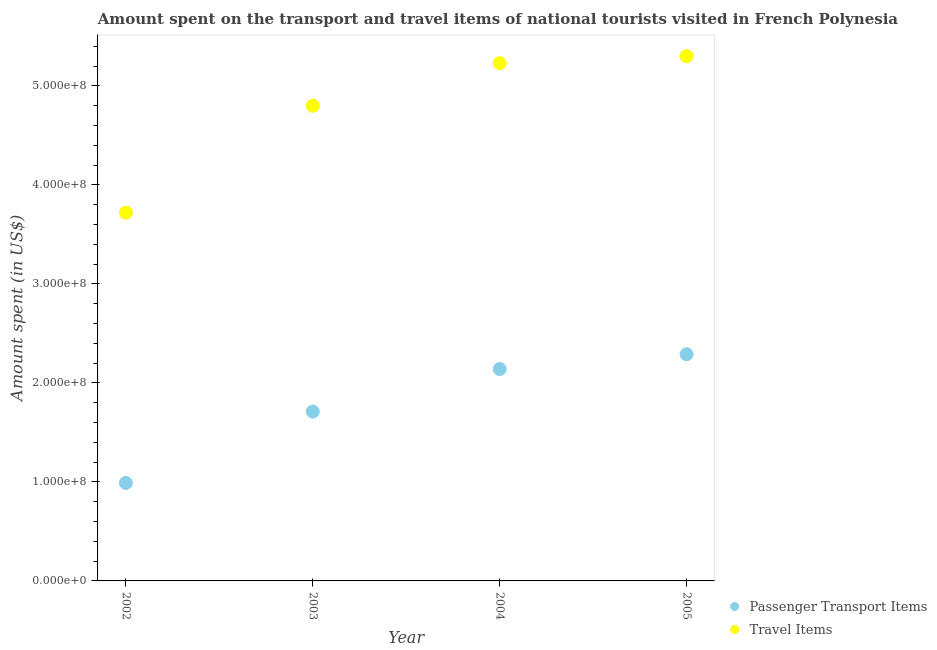How many different coloured dotlines are there?
Ensure brevity in your answer.  2. What is the amount spent in travel items in 2003?
Your answer should be very brief. 4.80e+08. Across all years, what is the maximum amount spent in travel items?
Offer a terse response. 5.30e+08. Across all years, what is the minimum amount spent on passenger transport items?
Give a very brief answer. 9.90e+07. In which year was the amount spent in travel items maximum?
Your response must be concise. 2005. What is the total amount spent on passenger transport items in the graph?
Provide a succinct answer. 7.13e+08. What is the difference between the amount spent on passenger transport items in 2004 and that in 2005?
Make the answer very short. -1.50e+07. What is the difference between the amount spent in travel items in 2002 and the amount spent on passenger transport items in 2004?
Ensure brevity in your answer.  1.58e+08. What is the average amount spent in travel items per year?
Ensure brevity in your answer.  4.76e+08. In the year 2003, what is the difference between the amount spent in travel items and amount spent on passenger transport items?
Offer a very short reply. 3.09e+08. In how many years, is the amount spent on passenger transport items greater than 160000000 US$?
Provide a succinct answer. 3. What is the ratio of the amount spent in travel items in 2003 to that in 2004?
Offer a terse response. 0.92. Is the amount spent in travel items in 2002 less than that in 2005?
Ensure brevity in your answer.  Yes. Is the difference between the amount spent in travel items in 2003 and 2004 greater than the difference between the amount spent on passenger transport items in 2003 and 2004?
Your response must be concise. No. What is the difference between the highest and the second highest amount spent in travel items?
Offer a very short reply. 7.00e+06. What is the difference between the highest and the lowest amount spent on passenger transport items?
Give a very brief answer. 1.30e+08. How many dotlines are there?
Your answer should be very brief. 2. Does the graph contain any zero values?
Offer a terse response. No. How many legend labels are there?
Ensure brevity in your answer.  2. What is the title of the graph?
Your answer should be very brief. Amount spent on the transport and travel items of national tourists visited in French Polynesia. What is the label or title of the Y-axis?
Offer a terse response. Amount spent (in US$). What is the Amount spent (in US$) of Passenger Transport Items in 2002?
Your answer should be compact. 9.90e+07. What is the Amount spent (in US$) in Travel Items in 2002?
Your answer should be compact. 3.72e+08. What is the Amount spent (in US$) in Passenger Transport Items in 2003?
Your response must be concise. 1.71e+08. What is the Amount spent (in US$) of Travel Items in 2003?
Ensure brevity in your answer.  4.80e+08. What is the Amount spent (in US$) of Passenger Transport Items in 2004?
Your answer should be very brief. 2.14e+08. What is the Amount spent (in US$) in Travel Items in 2004?
Offer a very short reply. 5.23e+08. What is the Amount spent (in US$) of Passenger Transport Items in 2005?
Your answer should be very brief. 2.29e+08. What is the Amount spent (in US$) in Travel Items in 2005?
Your response must be concise. 5.30e+08. Across all years, what is the maximum Amount spent (in US$) in Passenger Transport Items?
Offer a very short reply. 2.29e+08. Across all years, what is the maximum Amount spent (in US$) of Travel Items?
Provide a succinct answer. 5.30e+08. Across all years, what is the minimum Amount spent (in US$) of Passenger Transport Items?
Your answer should be compact. 9.90e+07. Across all years, what is the minimum Amount spent (in US$) of Travel Items?
Make the answer very short. 3.72e+08. What is the total Amount spent (in US$) in Passenger Transport Items in the graph?
Offer a terse response. 7.13e+08. What is the total Amount spent (in US$) of Travel Items in the graph?
Ensure brevity in your answer.  1.90e+09. What is the difference between the Amount spent (in US$) in Passenger Transport Items in 2002 and that in 2003?
Give a very brief answer. -7.20e+07. What is the difference between the Amount spent (in US$) of Travel Items in 2002 and that in 2003?
Offer a terse response. -1.08e+08. What is the difference between the Amount spent (in US$) of Passenger Transport Items in 2002 and that in 2004?
Offer a very short reply. -1.15e+08. What is the difference between the Amount spent (in US$) of Travel Items in 2002 and that in 2004?
Give a very brief answer. -1.51e+08. What is the difference between the Amount spent (in US$) of Passenger Transport Items in 2002 and that in 2005?
Give a very brief answer. -1.30e+08. What is the difference between the Amount spent (in US$) in Travel Items in 2002 and that in 2005?
Your answer should be very brief. -1.58e+08. What is the difference between the Amount spent (in US$) of Passenger Transport Items in 2003 and that in 2004?
Your answer should be very brief. -4.30e+07. What is the difference between the Amount spent (in US$) in Travel Items in 2003 and that in 2004?
Make the answer very short. -4.30e+07. What is the difference between the Amount spent (in US$) in Passenger Transport Items in 2003 and that in 2005?
Offer a very short reply. -5.80e+07. What is the difference between the Amount spent (in US$) of Travel Items in 2003 and that in 2005?
Your answer should be compact. -5.00e+07. What is the difference between the Amount spent (in US$) of Passenger Transport Items in 2004 and that in 2005?
Make the answer very short. -1.50e+07. What is the difference between the Amount spent (in US$) of Travel Items in 2004 and that in 2005?
Give a very brief answer. -7.00e+06. What is the difference between the Amount spent (in US$) in Passenger Transport Items in 2002 and the Amount spent (in US$) in Travel Items in 2003?
Make the answer very short. -3.81e+08. What is the difference between the Amount spent (in US$) of Passenger Transport Items in 2002 and the Amount spent (in US$) of Travel Items in 2004?
Keep it short and to the point. -4.24e+08. What is the difference between the Amount spent (in US$) of Passenger Transport Items in 2002 and the Amount spent (in US$) of Travel Items in 2005?
Make the answer very short. -4.31e+08. What is the difference between the Amount spent (in US$) of Passenger Transport Items in 2003 and the Amount spent (in US$) of Travel Items in 2004?
Ensure brevity in your answer.  -3.52e+08. What is the difference between the Amount spent (in US$) in Passenger Transport Items in 2003 and the Amount spent (in US$) in Travel Items in 2005?
Your response must be concise. -3.59e+08. What is the difference between the Amount spent (in US$) of Passenger Transport Items in 2004 and the Amount spent (in US$) of Travel Items in 2005?
Your answer should be very brief. -3.16e+08. What is the average Amount spent (in US$) of Passenger Transport Items per year?
Offer a terse response. 1.78e+08. What is the average Amount spent (in US$) in Travel Items per year?
Provide a succinct answer. 4.76e+08. In the year 2002, what is the difference between the Amount spent (in US$) of Passenger Transport Items and Amount spent (in US$) of Travel Items?
Your response must be concise. -2.73e+08. In the year 2003, what is the difference between the Amount spent (in US$) of Passenger Transport Items and Amount spent (in US$) of Travel Items?
Your answer should be very brief. -3.09e+08. In the year 2004, what is the difference between the Amount spent (in US$) in Passenger Transport Items and Amount spent (in US$) in Travel Items?
Make the answer very short. -3.09e+08. In the year 2005, what is the difference between the Amount spent (in US$) in Passenger Transport Items and Amount spent (in US$) in Travel Items?
Your response must be concise. -3.01e+08. What is the ratio of the Amount spent (in US$) of Passenger Transport Items in 2002 to that in 2003?
Give a very brief answer. 0.58. What is the ratio of the Amount spent (in US$) in Travel Items in 2002 to that in 2003?
Offer a terse response. 0.78. What is the ratio of the Amount spent (in US$) of Passenger Transport Items in 2002 to that in 2004?
Offer a terse response. 0.46. What is the ratio of the Amount spent (in US$) in Travel Items in 2002 to that in 2004?
Offer a terse response. 0.71. What is the ratio of the Amount spent (in US$) in Passenger Transport Items in 2002 to that in 2005?
Ensure brevity in your answer.  0.43. What is the ratio of the Amount spent (in US$) in Travel Items in 2002 to that in 2005?
Keep it short and to the point. 0.7. What is the ratio of the Amount spent (in US$) in Passenger Transport Items in 2003 to that in 2004?
Your answer should be compact. 0.8. What is the ratio of the Amount spent (in US$) of Travel Items in 2003 to that in 2004?
Your answer should be compact. 0.92. What is the ratio of the Amount spent (in US$) of Passenger Transport Items in 2003 to that in 2005?
Provide a succinct answer. 0.75. What is the ratio of the Amount spent (in US$) in Travel Items in 2003 to that in 2005?
Provide a short and direct response. 0.91. What is the ratio of the Amount spent (in US$) of Passenger Transport Items in 2004 to that in 2005?
Offer a terse response. 0.93. What is the difference between the highest and the second highest Amount spent (in US$) in Passenger Transport Items?
Provide a succinct answer. 1.50e+07. What is the difference between the highest and the second highest Amount spent (in US$) in Travel Items?
Offer a very short reply. 7.00e+06. What is the difference between the highest and the lowest Amount spent (in US$) of Passenger Transport Items?
Ensure brevity in your answer.  1.30e+08. What is the difference between the highest and the lowest Amount spent (in US$) of Travel Items?
Make the answer very short. 1.58e+08. 